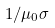Convert formula to latex. <formula><loc_0><loc_0><loc_500><loc_500>1 / \mu _ { 0 } \sigma</formula> 